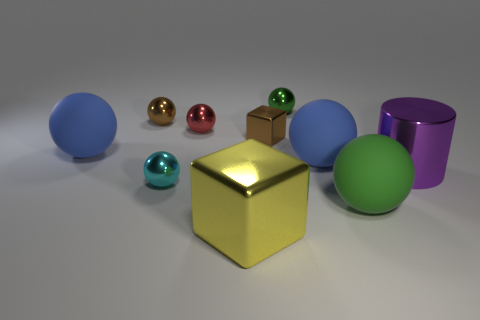How many green spheres must be subtracted to get 1 green spheres? 1 Subtract all cyan blocks. How many green balls are left? 2 Subtract all blue balls. How many balls are left? 5 Subtract all big spheres. How many spheres are left? 4 Subtract 3 balls. How many balls are left? 4 Subtract all yellow spheres. Subtract all brown cylinders. How many spheres are left? 7 Subtract all cylinders. How many objects are left? 9 Subtract all purple rubber blocks. Subtract all matte balls. How many objects are left? 7 Add 1 big yellow metal blocks. How many big yellow metal blocks are left? 2 Add 4 large cylinders. How many large cylinders exist? 5 